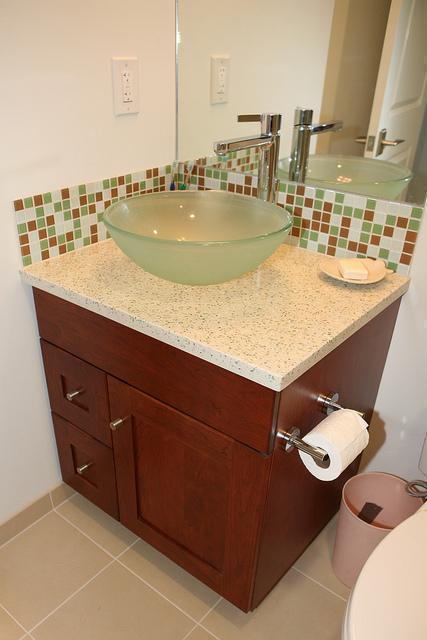What is the green bowl on the counter used for?
Answer the question by selecting the correct answer among the 4 following choices.
Options: Eating, sifting, cooking, catching water. Catching water. 